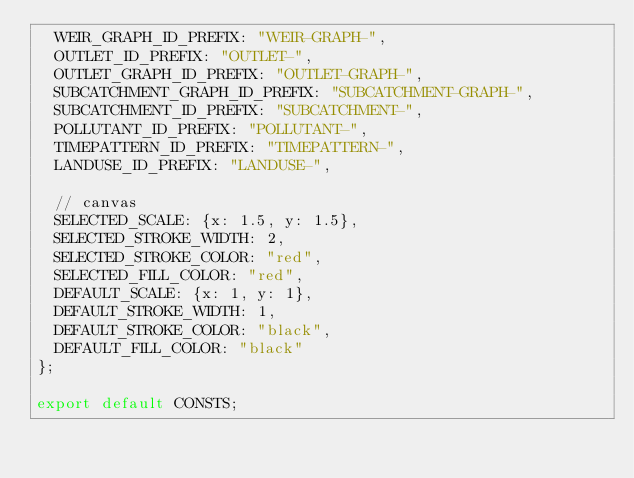Convert code to text. <code><loc_0><loc_0><loc_500><loc_500><_TypeScript_>  WEIR_GRAPH_ID_PREFIX: "WEIR-GRAPH-",
  OUTLET_ID_PREFIX: "OUTLET-",
  OUTLET_GRAPH_ID_PREFIX: "OUTLET-GRAPH-",
  SUBCATCHMENT_GRAPH_ID_PREFIX: "SUBCATCHMENT-GRAPH-",
  SUBCATCHMENT_ID_PREFIX: "SUBCATCHMENT-",
  POLLUTANT_ID_PREFIX: "POLLUTANT-",
  TIMEPATTERN_ID_PREFIX: "TIMEPATTERN-",
  LANDUSE_ID_PREFIX: "LANDUSE-",

  // canvas
  SELECTED_SCALE: {x: 1.5, y: 1.5},
  SELECTED_STROKE_WIDTH: 2,
  SELECTED_STROKE_COLOR: "red",
  SELECTED_FILL_COLOR: "red",
  DEFAULT_SCALE: {x: 1, y: 1},
  DEFAULT_STROKE_WIDTH: 1,
  DEFAULT_STROKE_COLOR: "black",
  DEFAULT_FILL_COLOR: "black"
};

export default CONSTS;
</code> 